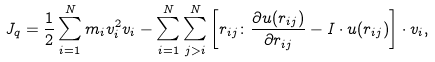Convert formula to latex. <formula><loc_0><loc_0><loc_500><loc_500>J _ { q } = \frac { 1 } { 2 } \sum _ { i = 1 } ^ { N } m _ { i } v _ { i } ^ { 2 } v _ { i } - \sum _ { i = 1 } ^ { N } \sum _ { j > i } ^ { N } \left [ r _ { i j } \colon \frac { \partial u ( r _ { i j } ) } { \partial r _ { i j } } - I \cdot u ( r _ { i j } ) \right ] \cdot v _ { i } ,</formula> 